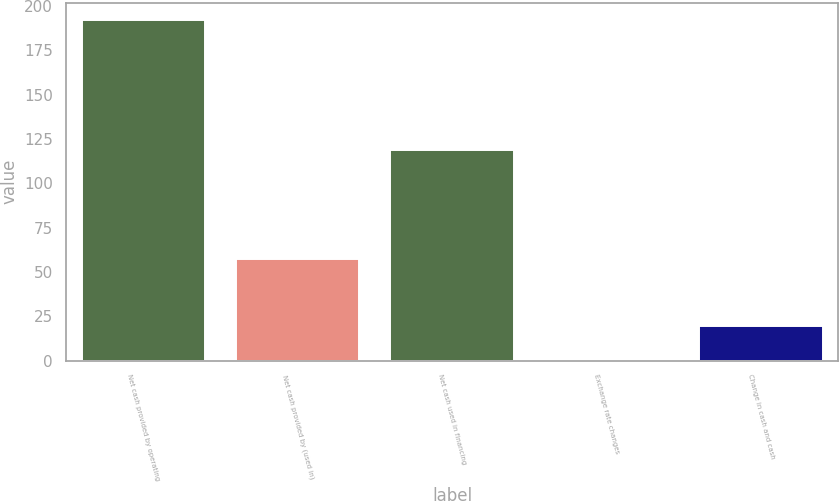Convert chart to OTSL. <chart><loc_0><loc_0><loc_500><loc_500><bar_chart><fcel>Net cash provided by operating<fcel>Net cash provided by (used in)<fcel>Net cash used in financing<fcel>Exchange rate changes<fcel>Change in cash and cash<nl><fcel>192.3<fcel>57.4<fcel>118.9<fcel>0.5<fcel>19.68<nl></chart> 